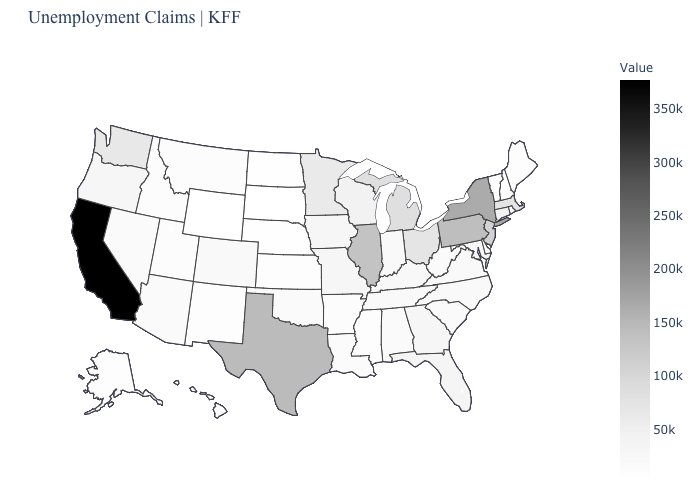Does Nevada have a higher value than Massachusetts?
Give a very brief answer. No. Which states have the highest value in the USA?
Give a very brief answer. California. Which states have the lowest value in the USA?
Write a very short answer. South Dakota. Does Florida have a higher value than Illinois?
Quick response, please. No. Which states hav the highest value in the South?
Be succinct. Texas. Does Michigan have a lower value than New York?
Quick response, please. Yes. 